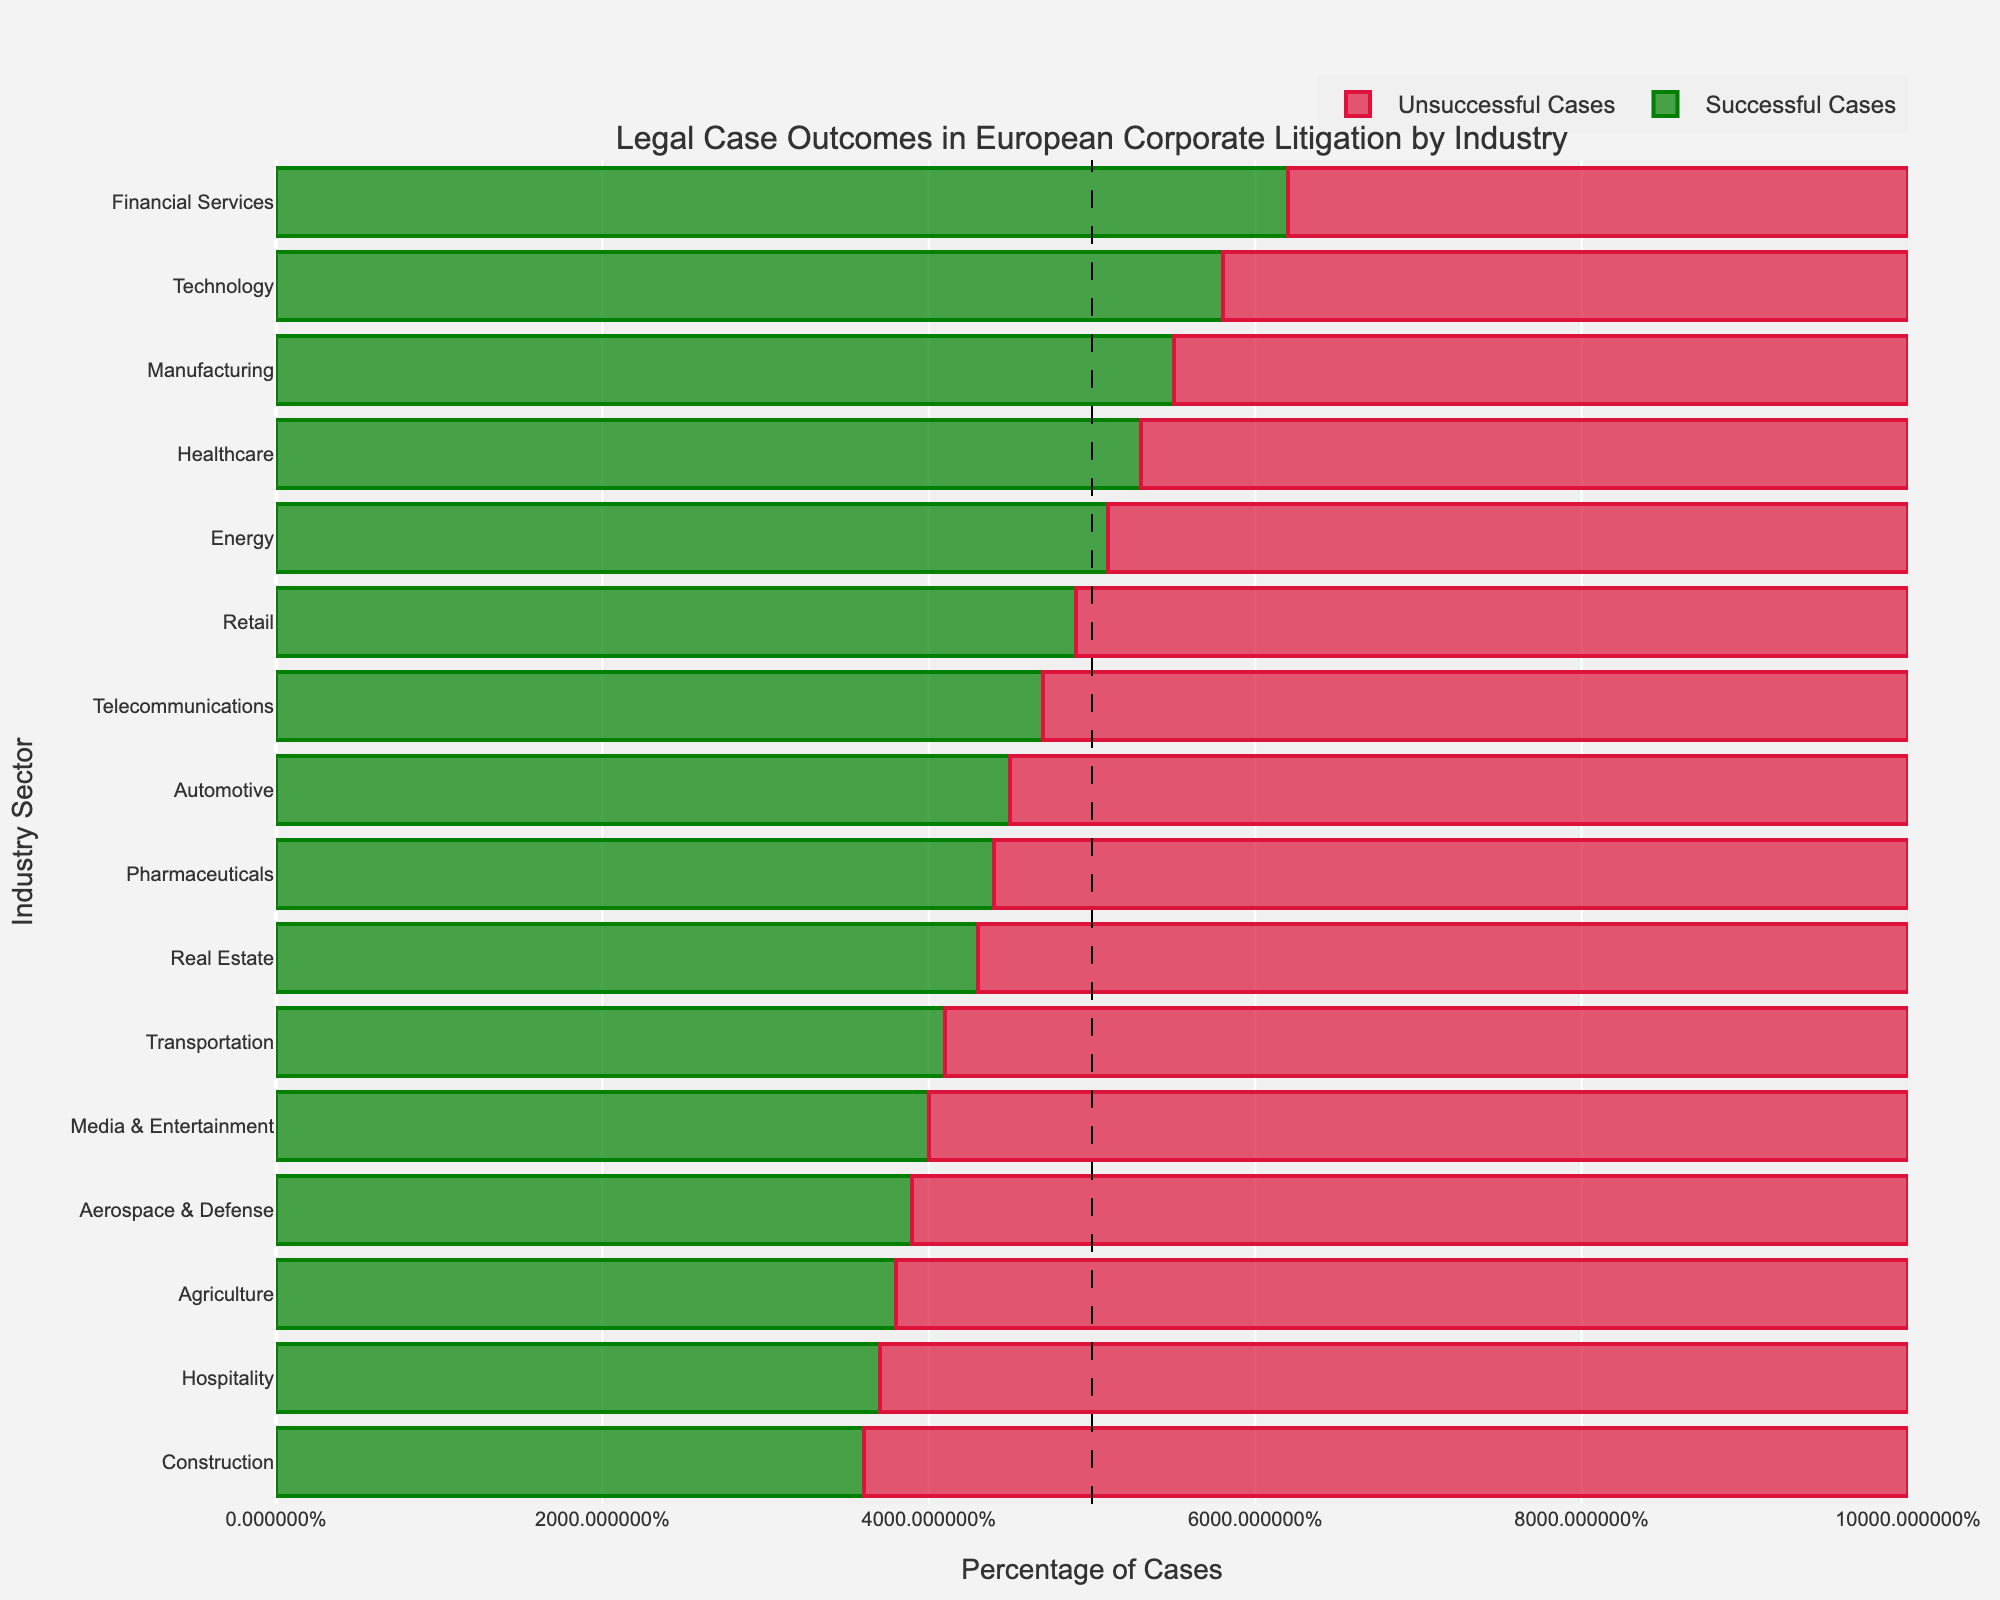Which industry has the highest percentage of successful cases? The figure shows green bars representing successful cases for each industry. The highest green bar represents the highest percentage of successful cases. Financial Services has the highest green bar at 62%.
Answer: Financial Services Which two industries have the closest percentages of successful cases? To find the closest percentages, we compare the green bars of each industry and see which two are closest in length. Healthcare is 53% and Energy is 51%, making their successful case percentages closest to each other.
Answer: Healthcare and Energy What is the combined percentage of unsuccessful cases in Real Estate and Pharmaceuticals? First, find the red bars for Real Estate and Pharmaceuticals, which are at 57% and 56% respectively. Add them together: 57% + 56% = 113%.
Answer: 113% How many industries have a success rate above 50%? Look for green bars longer than halfway (the 50% line). Financial Services, Technology, Manufacturing, Healthcare, and Energy all have more than 50% successful cases. There are five such industries.
Answer: 5 Which industry has the lowest percentage of successful cases? The smallest green bar represents the industry with the lowest percentage of successful cases. Construction has the smallest green bar, at 36%.
Answer: Construction Compare the successful cases' percentage between Technology and Media & Entertainment. Find Technology's green bar which is at 58%. Media & Entertainment's green bar is at 40%. 58% is greater than 40%.
Answer: Technology has a higher success rate What is the ratio of successful cases to unsuccessful cases in the Automotive industry? Automotive industry has 45% successful and 55% unsuccessful cases. The ratio is 45:55, which can be simplified to 9:11.
Answer: 9:11 Does the Energy sector have more successful cases than unsuccessful ones? The green and red bars for Energy are at 51% and 49% respectively. Since 51% > 49%, it has more successful cases.
Answer: Yes For which industries does the percentage of unsuccessful cases exceed 60%? Look for red bars longer than 60%. Media & Entertainment has an unsuccessful case percentage of 60%, and Aerospace & Defense, Agriculture, Hospitality, and Construction exceed 60%.
Answer: Media & Entertainment, Aerospace & Defense, Agriculture, Hospitality, Construction If you combine the successful case percentages of Financial Services, Technology, and Manufacturing, what would be the total? Add the successful case percentages for Financial Services (62%), Technology (58%), and Manufacturing (55%). So, 62% + 58% + 55% = 175%.
Answer: 175% 